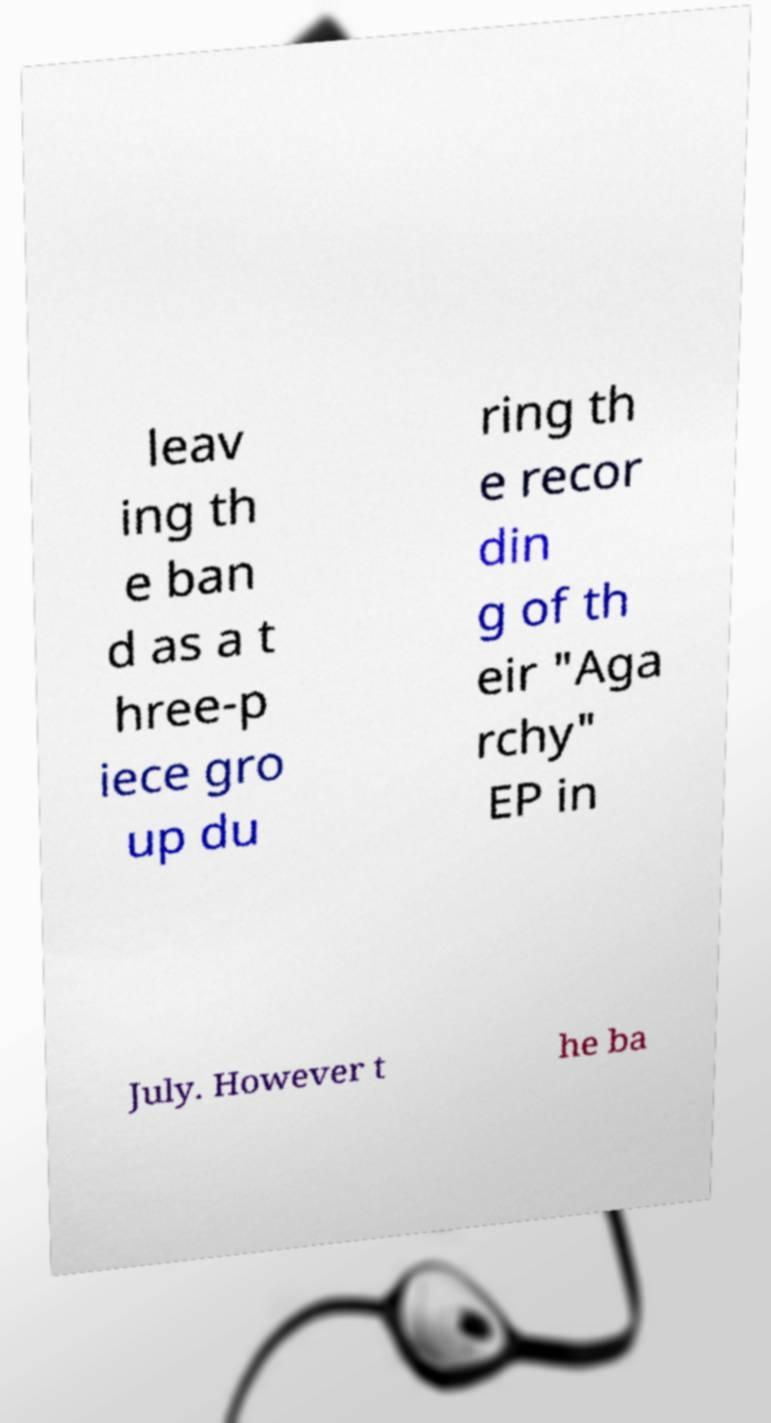Please identify and transcribe the text found in this image. leav ing th e ban d as a t hree-p iece gro up du ring th e recor din g of th eir "Aga rchy" EP in July. However t he ba 